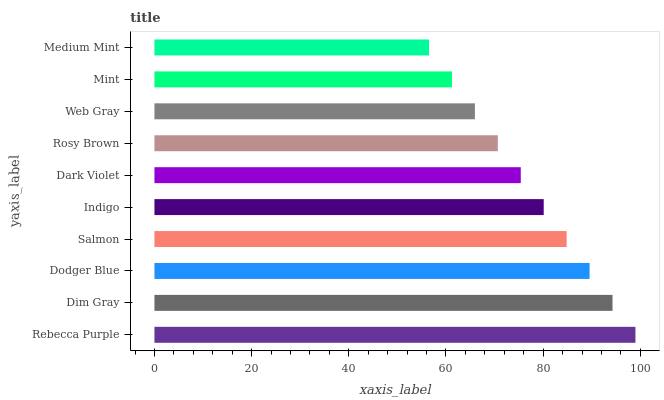Is Medium Mint the minimum?
Answer yes or no. Yes. Is Rebecca Purple the maximum?
Answer yes or no. Yes. Is Dim Gray the minimum?
Answer yes or no. No. Is Dim Gray the maximum?
Answer yes or no. No. Is Rebecca Purple greater than Dim Gray?
Answer yes or no. Yes. Is Dim Gray less than Rebecca Purple?
Answer yes or no. Yes. Is Dim Gray greater than Rebecca Purple?
Answer yes or no. No. Is Rebecca Purple less than Dim Gray?
Answer yes or no. No. Is Indigo the high median?
Answer yes or no. Yes. Is Dark Violet the low median?
Answer yes or no. Yes. Is Web Gray the high median?
Answer yes or no. No. Is Rebecca Purple the low median?
Answer yes or no. No. 